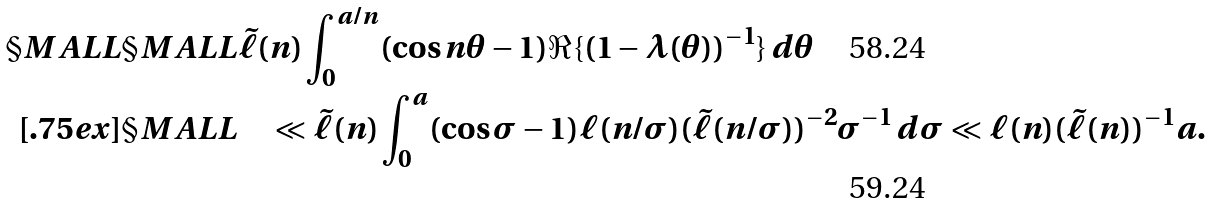Convert formula to latex. <formula><loc_0><loc_0><loc_500><loc_500>\S M A L L & \S M A L L \tilde { \ell } ( n ) \int _ { 0 } ^ { a / n } ( \cos n \theta - 1 ) \Re \{ ( 1 - \lambda ( \theta ) ) ^ { - 1 } \} \, d \theta \\ [ . 7 5 e x ] & \S M A L L \quad \ll \tilde { \ell } ( n ) \int _ { 0 } ^ { a } ( \cos \sigma - 1 ) \ell ( n / \sigma ) ( \tilde { \ell } ( n / \sigma ) ) ^ { - 2 } \sigma ^ { - 1 } \, d \sigma \ll \ell ( n ) ( \tilde { \ell } ( n ) ) ^ { - 1 } a .</formula> 